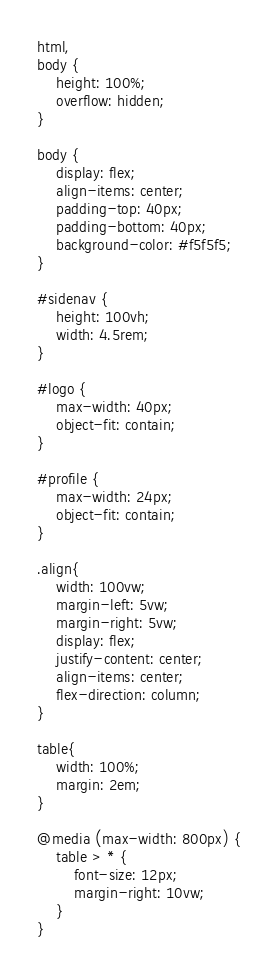<code> <loc_0><loc_0><loc_500><loc_500><_CSS_>html,
body {
    height: 100%;
    overflow: hidden;
}

body {
    display: flex;
    align-items: center;
    padding-top: 40px;
    padding-bottom: 40px;
    background-color: #f5f5f5;
}

#sidenav {
    height: 100vh;
    width: 4.5rem;
}

#logo {
    max-width: 40px;
    object-fit: contain;
}

#profile {
    max-width: 24px;
    object-fit: contain;
}

.align{
    width: 100vw;
    margin-left: 5vw;
    margin-right: 5vw;
    display: flex;
    justify-content: center;
    align-items: center;
    flex-direction: column;
}

table{
    width: 100%;
    margin: 2em;
}

@media (max-width: 800px) {
    table > * {
        font-size: 12px;
        margin-right: 10vw;
    }
}</code> 